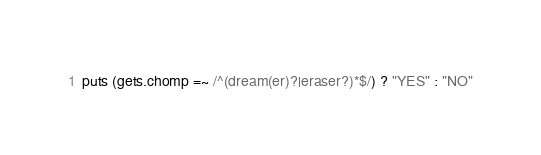Convert code to text. <code><loc_0><loc_0><loc_500><loc_500><_Ruby_>puts (gets.chomp =~ /^(dream(er)?|eraser?)*$/) ? "YES" : "NO"</code> 